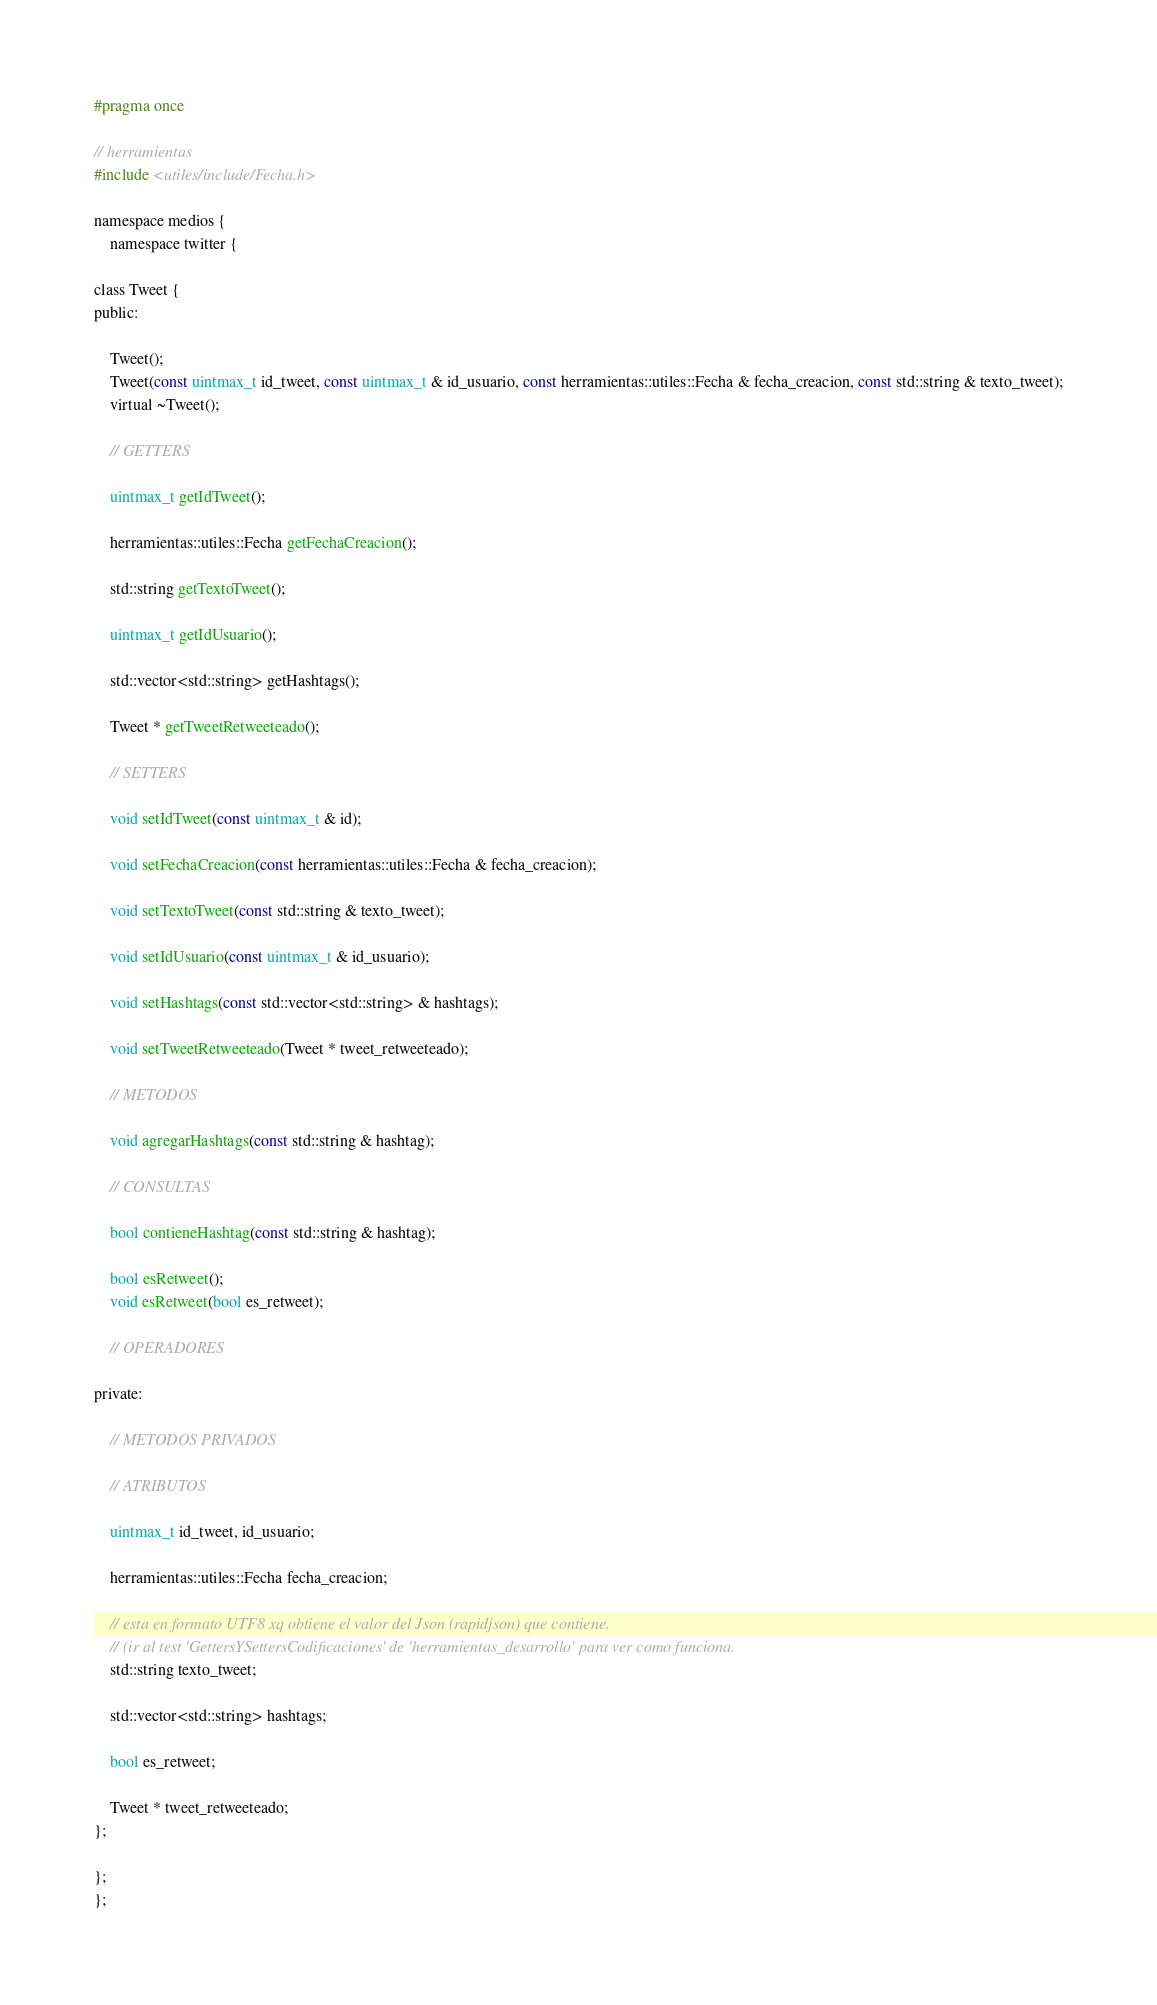Convert code to text. <code><loc_0><loc_0><loc_500><loc_500><_C_>#pragma once

// herramientas
#include <utiles/include/Fecha.h>

namespace medios {
    namespace twitter {

class Tweet {
public:

    Tweet();
    Tweet(const uintmax_t id_tweet, const uintmax_t & id_usuario, const herramientas::utiles::Fecha & fecha_creacion, const std::string & texto_tweet);
	virtual ~Tweet();

    // GETTERS

    uintmax_t getIdTweet();

    herramientas::utiles::Fecha getFechaCreacion();

    std::string getTextoTweet();

    uintmax_t getIdUsuario();

    std::vector<std::string> getHashtags();

    Tweet * getTweetRetweeteado();

    // SETTERS

    void setIdTweet(const uintmax_t & id);

    void setFechaCreacion(const herramientas::utiles::Fecha & fecha_creacion);

    void setTextoTweet(const std::string & texto_tweet);

    void setIdUsuario(const uintmax_t & id_usuario);

    void setHashtags(const std::vector<std::string> & hashtags);
    
    void setTweetRetweeteado(Tweet * tweet_retweeteado);

    // METODOS

    void agregarHashtags(const std::string & hashtag);

    // CONSULTAS

    bool contieneHashtag(const std::string & hashtag);

    bool esRetweet();
    void esRetweet(bool es_retweet);

    // OPERADORES

private:

    // METODOS PRIVADOS

    // ATRIBUTOS

    uintmax_t id_tweet, id_usuario;

    herramientas::utiles::Fecha fecha_creacion;

    // esta en formato UTF8 xq obtiene el valor del Json (rapidjson) que contiene.
    // (ir al test 'GettersYSettersCodificaciones' de 'herramientas_desarrollo' para ver como funciona.
    std::string texto_tweet;

    std::vector<std::string> hashtags;

    bool es_retweet;

    Tweet * tweet_retweeteado;
};

};
};</code> 